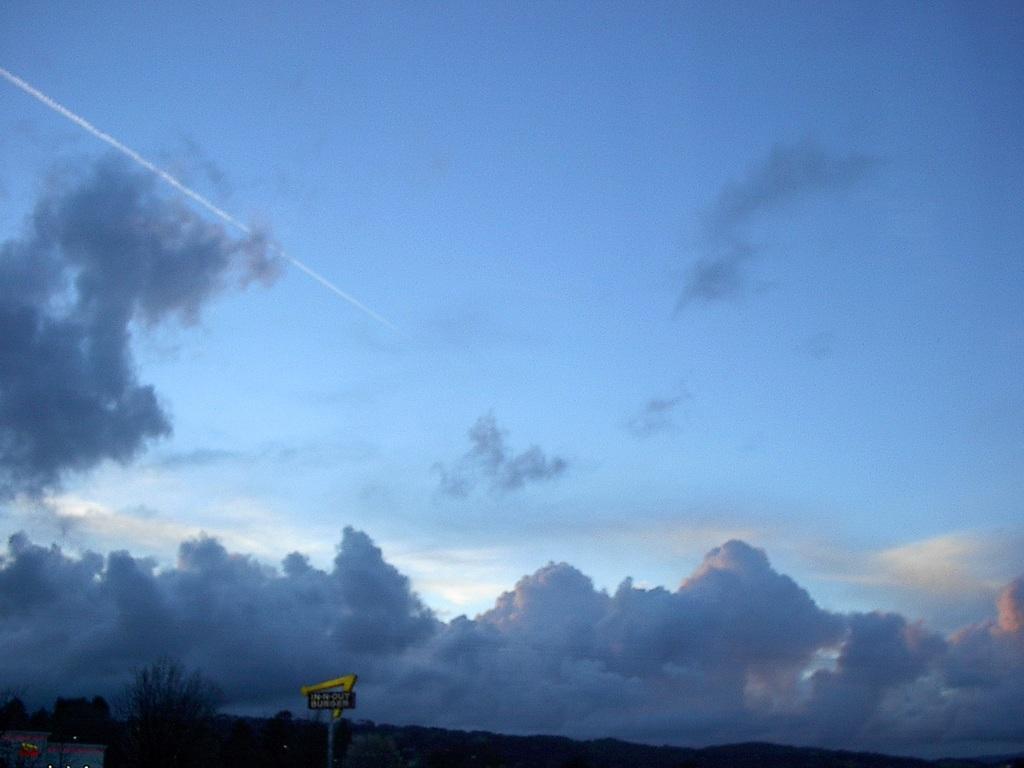Can you describe this image briefly? There is a board on the road and around the board there are some trees and in the background trees a blue sky and it looks like there is a meteoroid passed in the sky. 